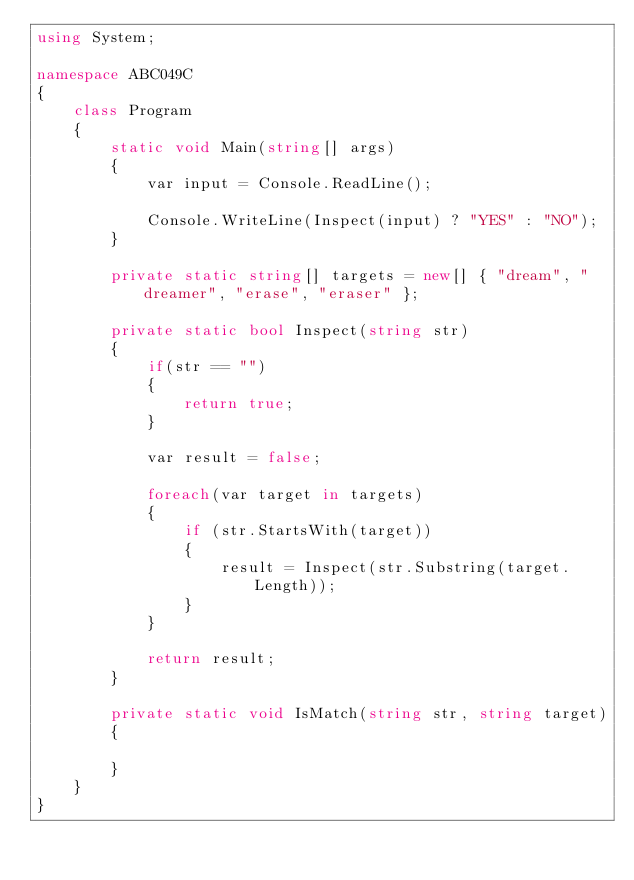<code> <loc_0><loc_0><loc_500><loc_500><_C#_>using System;

namespace ABC049C
{
    class Program
    {
        static void Main(string[] args)
        {
            var input = Console.ReadLine();

            Console.WriteLine(Inspect(input) ? "YES" : "NO");
        }

        private static string[] targets = new[] { "dream", "dreamer", "erase", "eraser" };

        private static bool Inspect(string str)
        {
            if(str == "")
            {
                return true;
            }

            var result = false;

            foreach(var target in targets)
            {
                if (str.StartsWith(target))
                {
                    result = Inspect(str.Substring(target.Length));
                }
            }

            return result;
        }

        private static void IsMatch(string str, string target)
        {

        }
    }
}</code> 